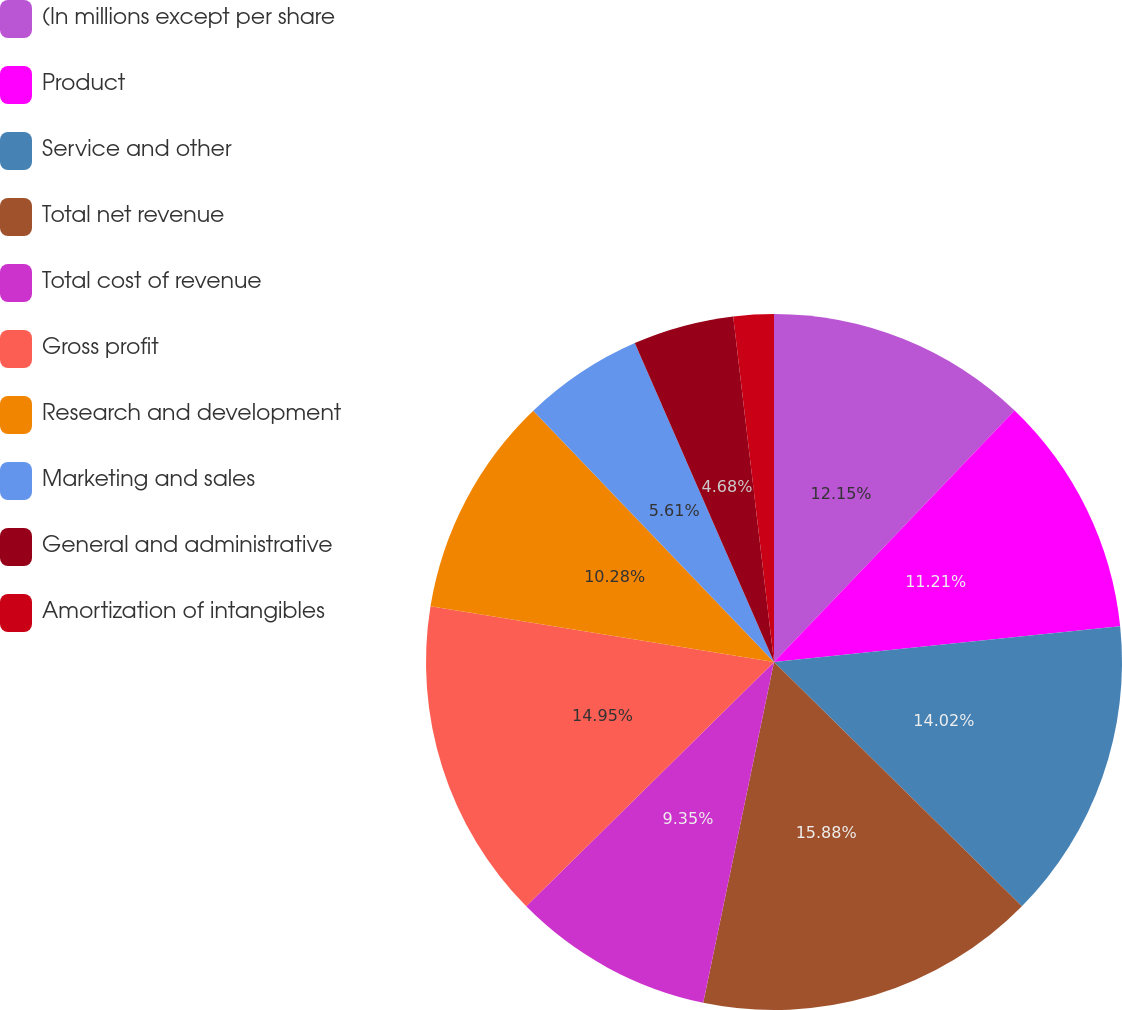Convert chart to OTSL. <chart><loc_0><loc_0><loc_500><loc_500><pie_chart><fcel>(In millions except per share<fcel>Product<fcel>Service and other<fcel>Total net revenue<fcel>Total cost of revenue<fcel>Gross profit<fcel>Research and development<fcel>Marketing and sales<fcel>General and administrative<fcel>Amortization of intangibles<nl><fcel>12.15%<fcel>11.21%<fcel>14.02%<fcel>15.88%<fcel>9.35%<fcel>14.95%<fcel>10.28%<fcel>5.61%<fcel>4.68%<fcel>1.87%<nl></chart> 